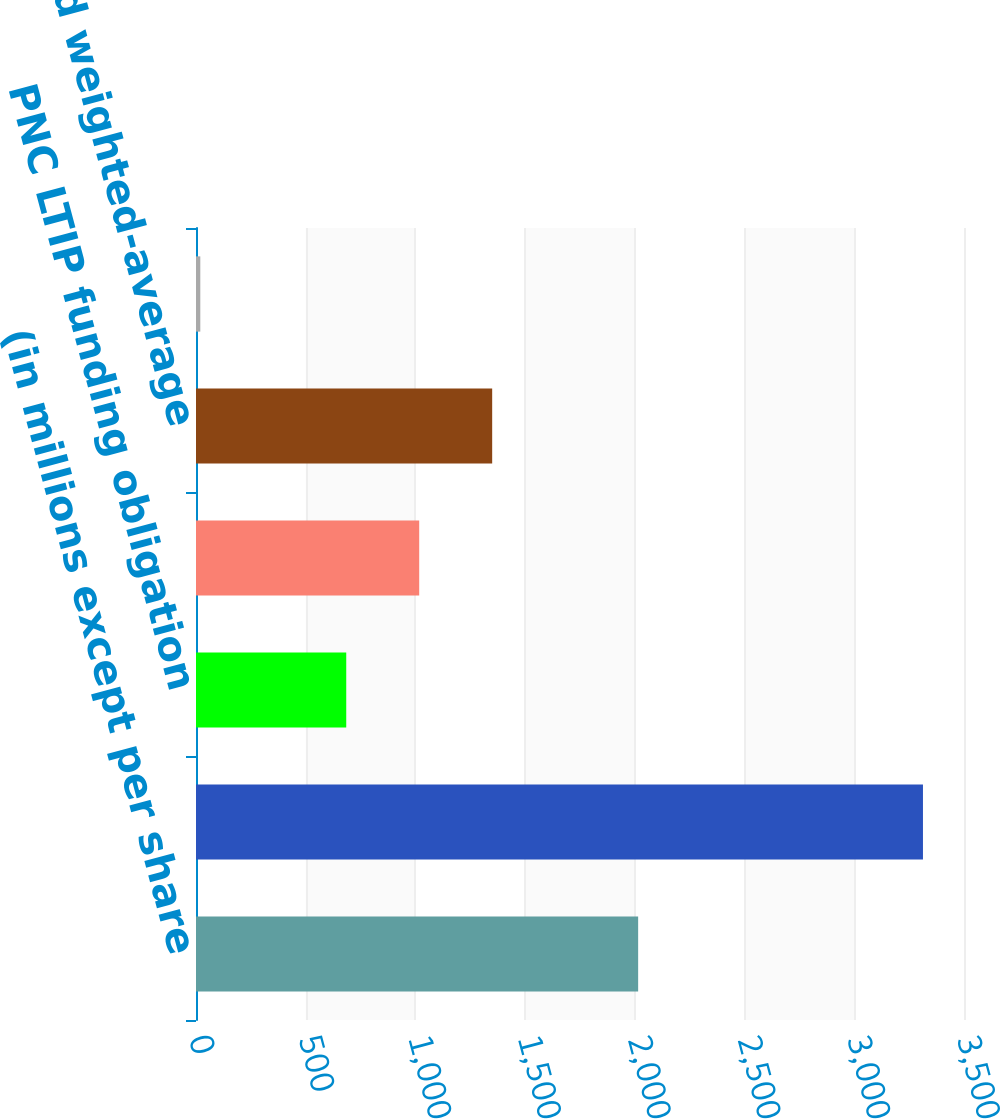Convert chart to OTSL. <chart><loc_0><loc_0><loc_500><loc_500><bar_chart><fcel>(in millions except per share<fcel>Net income attributable to<fcel>PNC LTIP funding obligation<fcel>Other income tax matters<fcel>Diluted weighted-average<fcel>Diluted earnings per common<nl><fcel>2015<fcel>3313<fcel>684.68<fcel>1017.22<fcel>1349.76<fcel>19.6<nl></chart> 